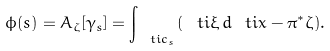<formula> <loc_0><loc_0><loc_500><loc_500>\phi ( s ) = A _ { \zeta } [ \gamma _ { s } ] = \int _ { \ t i { c } _ { s } } ( \ t i { \xi } \, d \ t i { x } - \pi ^ { * } \zeta ) .</formula> 